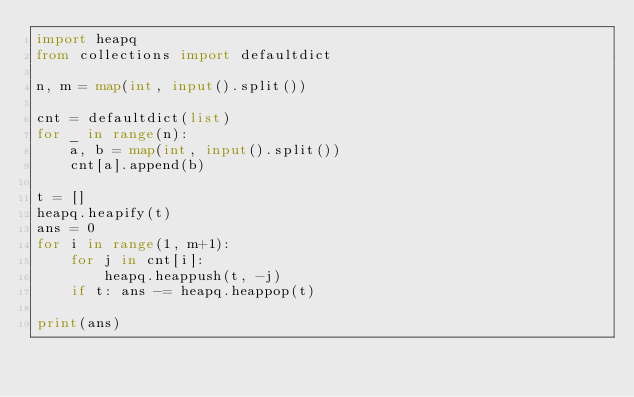<code> <loc_0><loc_0><loc_500><loc_500><_Python_>import heapq
from collections import defaultdict

n, m = map(int, input().split())

cnt = defaultdict(list)
for _ in range(n):
    a, b = map(int, input().split())
    cnt[a].append(b)

t = []
heapq.heapify(t)
ans = 0
for i in range(1, m+1):
    for j in cnt[i]:
        heapq.heappush(t, -j)
    if t: ans -= heapq.heappop(t)

print(ans)
</code> 